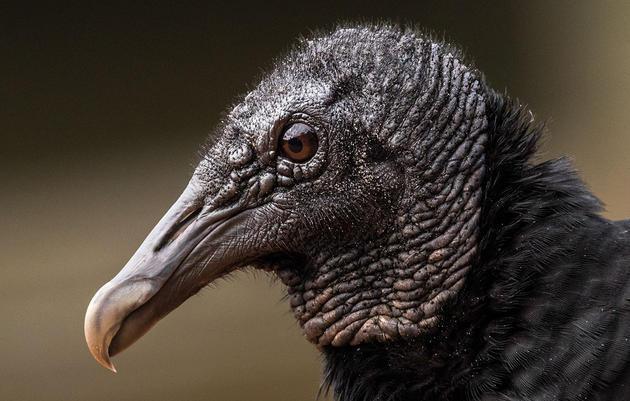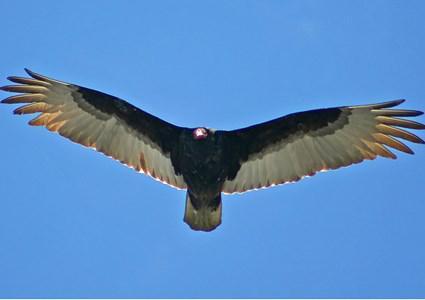The first image is the image on the left, the second image is the image on the right. For the images displayed, is the sentence "The vulture on the right image is flying facing right." factually correct? Answer yes or no. No. The first image is the image on the left, the second image is the image on the right. Examine the images to the left and right. Is the description "A total of three vultures are shown." accurate? Answer yes or no. No. 